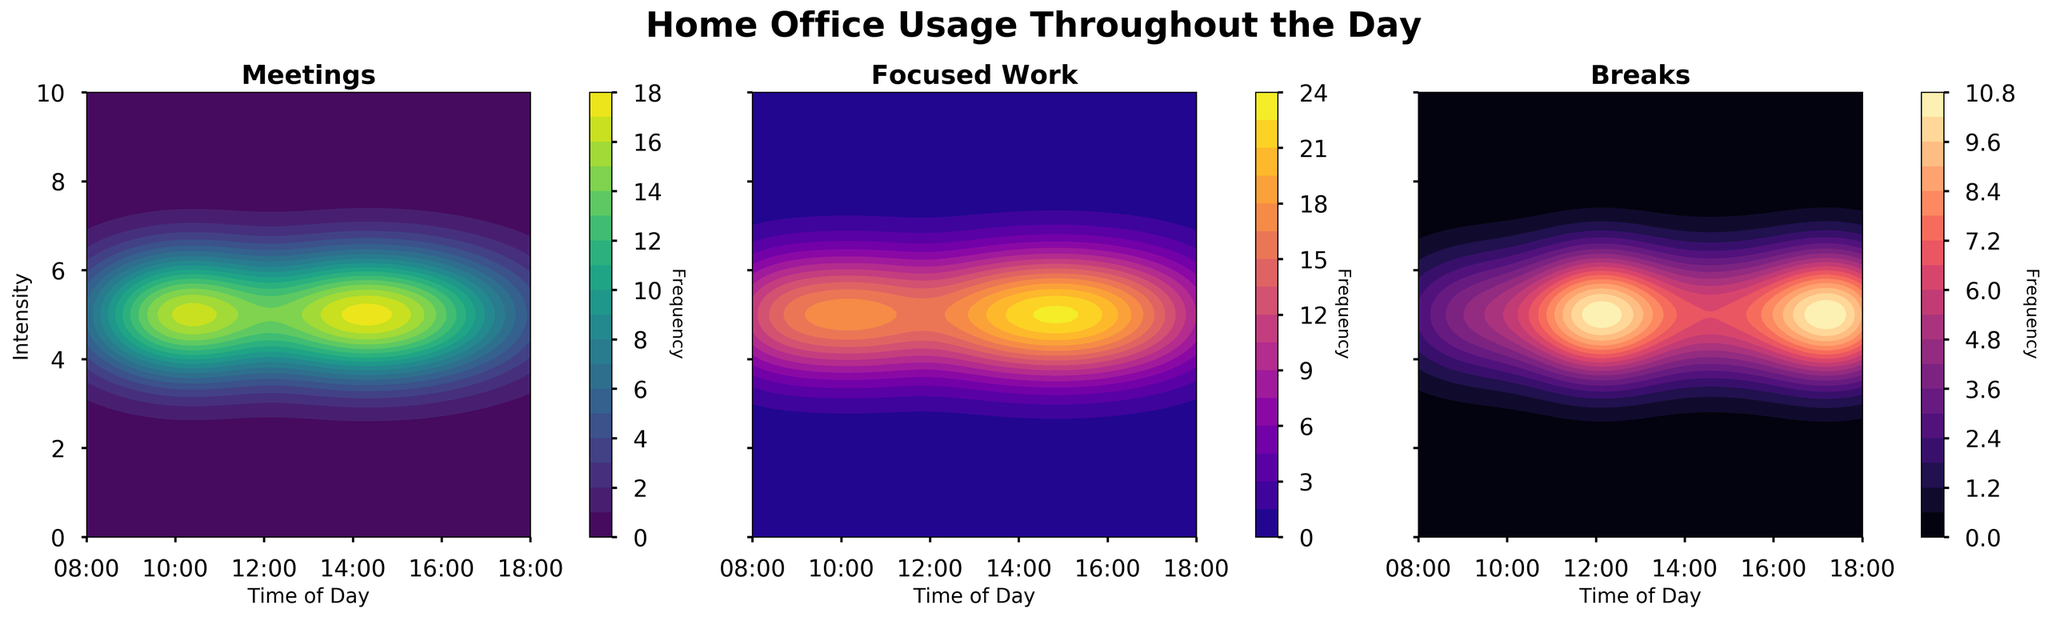What is the title of the figure? The title is usually located at the top of the figure. In this case, the title is 'Home Office Usage Throughout the Day'.
Answer: Home Office Usage Throughout the Day How many subplots are in the figure? By visually inspecting the figure, we see there are three separate subplots side by side.
Answer: 3 What type of work has the highest frequency at 15:00? To answer this, look at the 15:00 mark in each subplot and identify the highest intensity color. In the 'Focused Work' subplot, the intensity is highest.
Answer: Focused Work Which time of day has the highest overall usage across all types of work? Sum the intensities across the types of work at each hour and identify the hour with the highest total. The highest is around 15:00 primarily due to high focused work and meeting frequency.
Answer: 15:00 Which type of work has the most uniform usage throughout the day? By comparing the spread of intensities in each subplot, we see 'Focused Work' has a relatively uniform high intensity throughout the day compared to 'Meetings' and 'Breaks'.
Answer: Focused Work At what times do meetings peak during the day? Inspect the intensities in the 'Meetings' subplot. The highest peaks are at 10:00 and 14:00.
Answer: 10:00 and 14:00 For what time range do breaks show heightened frequency? Look at the 'Breaks' subplot and observe the intensities. The intensity peaks notably around 12:00, with another smaller peak at 17:00 and 18:00.
Answer: 12:00, 17:00-18:00 Which type of work shows the most significant drop in frequency from morning to afternoon? Comparing the 'Meetings' subplot with the others, we see that 'Meetings' frequency drops notably from a peak in the morning to the afternoon.
Answer: Meetings What is the approximate frequency of focused work at 08:00? Refer to the 'Focused Work' subplot at 08:00. The color intensity suggests a frequency slightly below 7, around 6 according to the provided data.
Answer: 6 Between which hours does the frequency of break activities nearly remain constant? Inspect the 'Breaks' subplot for periods where the intensity does not vary much. Between 10:00 and 16:00, the frequency remains relatively low and nearly constant.
Answer: 10:00- 16:00 